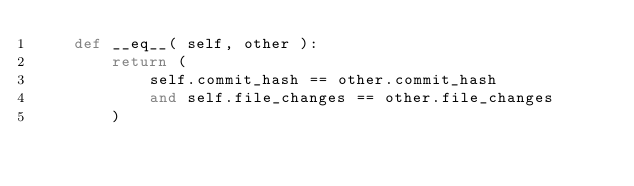<code> <loc_0><loc_0><loc_500><loc_500><_Python_>    def __eq__( self, other ):
        return (
            self.commit_hash == other.commit_hash
            and self.file_changes == other.file_changes
        )
</code> 